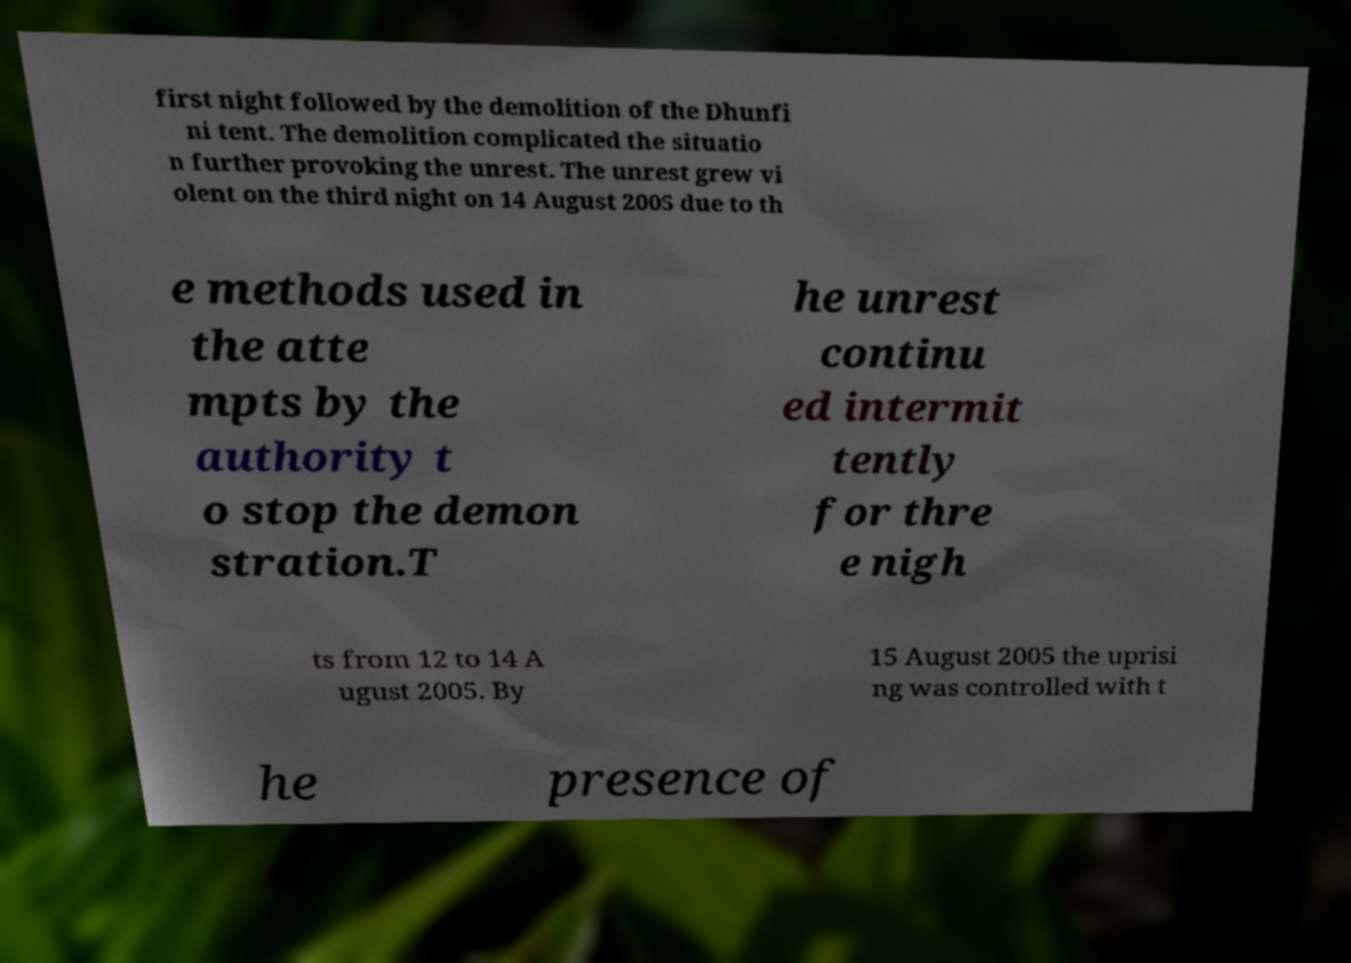What messages or text are displayed in this image? I need them in a readable, typed format. first night followed by the demolition of the Dhunfi ni tent. The demolition complicated the situatio n further provoking the unrest. The unrest grew vi olent on the third night on 14 August 2005 due to th e methods used in the atte mpts by the authority t o stop the demon stration.T he unrest continu ed intermit tently for thre e nigh ts from 12 to 14 A ugust 2005. By 15 August 2005 the uprisi ng was controlled with t he presence of 